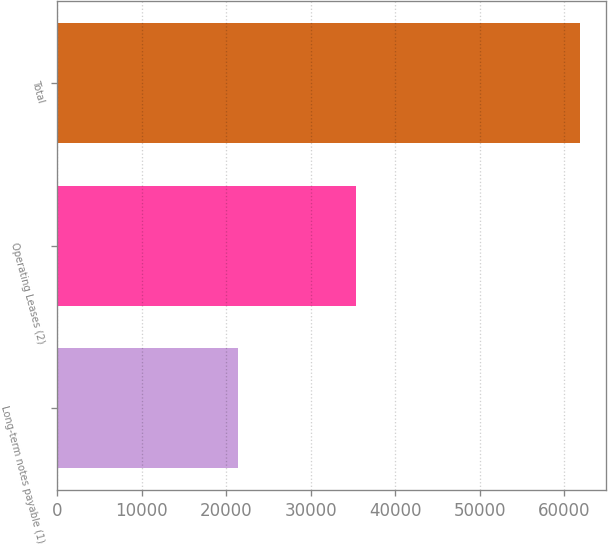<chart> <loc_0><loc_0><loc_500><loc_500><bar_chart><fcel>Long-term notes payable (1)<fcel>Operating Leases (2)<fcel>Total<nl><fcel>21388<fcel>35419<fcel>61869<nl></chart> 